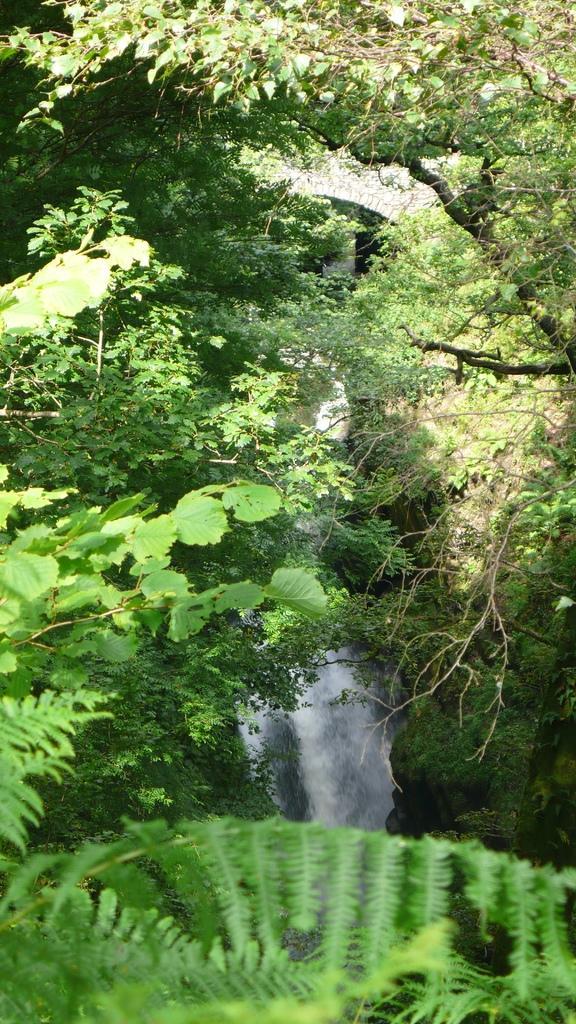Could you give a brief overview of what you see in this image? This image consists of trees, water, grass and a wall. This image taken, maybe during a day. 